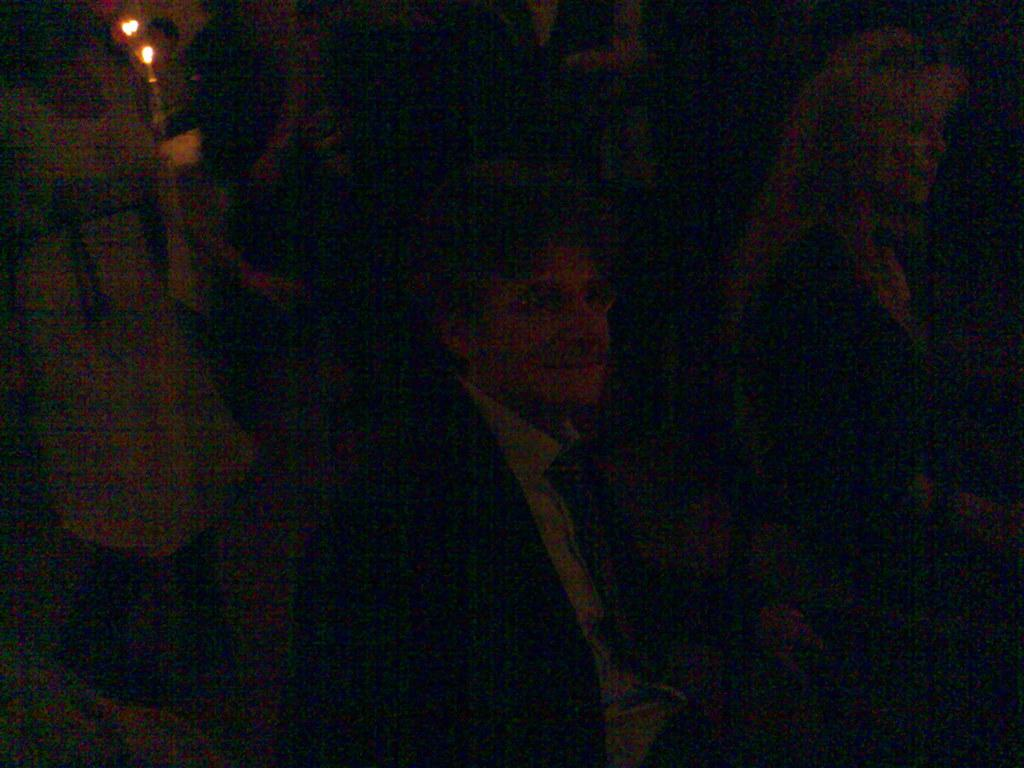What is present in the image? There is a person and lights in the image. Can you describe the lighting in the image? The image is dark, but there are lights visible. What type of metal is the person's mouth made of in the image? There is no indication of the person's mouth or any metal in the image. 